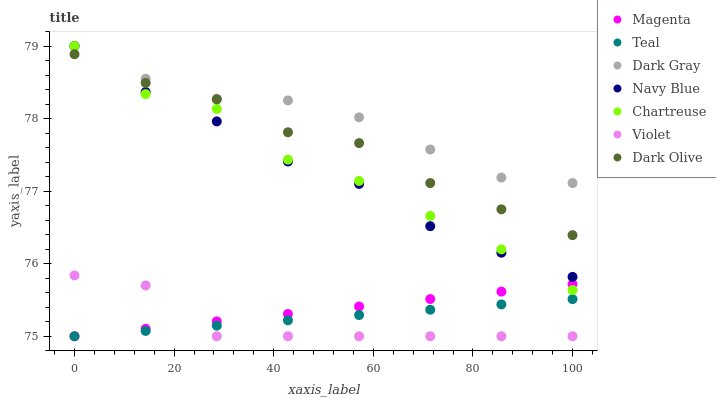Does Violet have the minimum area under the curve?
Answer yes or no. Yes. Does Dark Gray have the maximum area under the curve?
Answer yes or no. Yes. Does Dark Olive have the minimum area under the curve?
Answer yes or no. No. Does Dark Olive have the maximum area under the curve?
Answer yes or no. No. Is Magenta the smoothest?
Answer yes or no. Yes. Is Chartreuse the roughest?
Answer yes or no. Yes. Is Dark Olive the smoothest?
Answer yes or no. No. Is Dark Olive the roughest?
Answer yes or no. No. Does Teal have the lowest value?
Answer yes or no. Yes. Does Dark Olive have the lowest value?
Answer yes or no. No. Does Chartreuse have the highest value?
Answer yes or no. Yes. Does Dark Olive have the highest value?
Answer yes or no. No. Is Teal less than Dark Gray?
Answer yes or no. Yes. Is Dark Gray greater than Dark Olive?
Answer yes or no. Yes. Does Chartreuse intersect Dark Gray?
Answer yes or no. Yes. Is Chartreuse less than Dark Gray?
Answer yes or no. No. Is Chartreuse greater than Dark Gray?
Answer yes or no. No. Does Teal intersect Dark Gray?
Answer yes or no. No. 